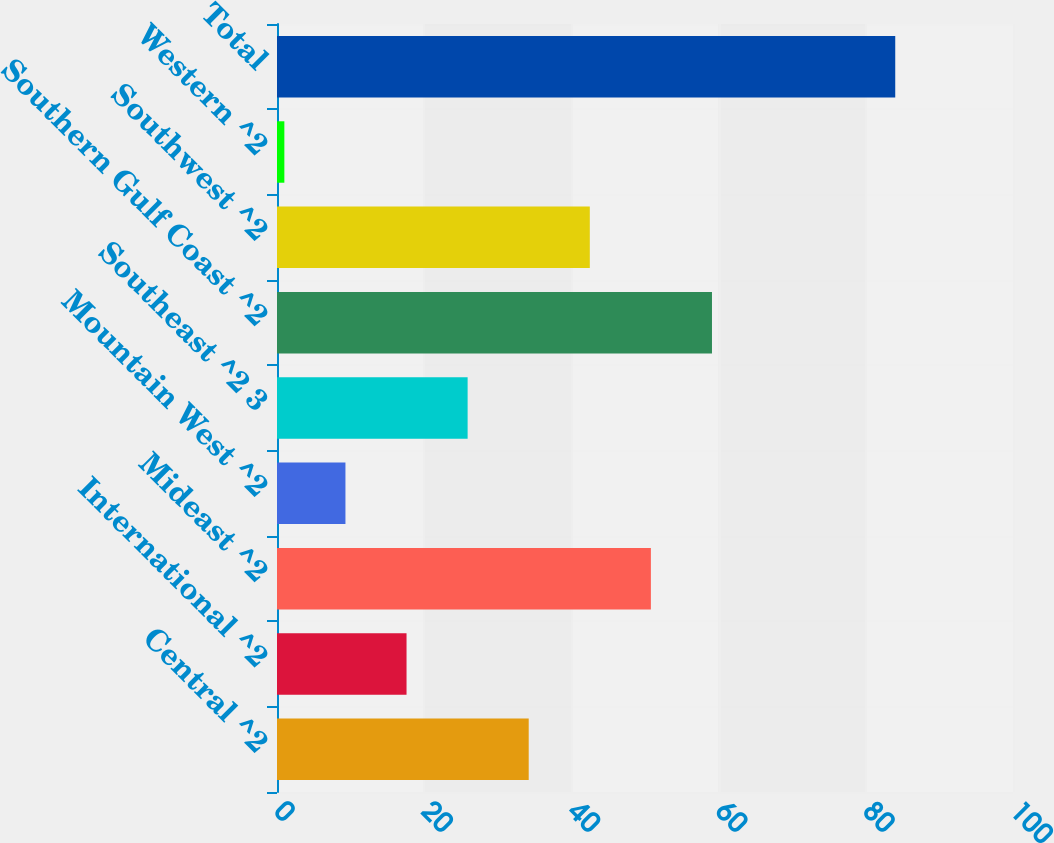Convert chart to OTSL. <chart><loc_0><loc_0><loc_500><loc_500><bar_chart><fcel>Central ^2<fcel>International ^2<fcel>Mideast ^2<fcel>Mountain West ^2<fcel>Southeast ^2 3<fcel>Southern Gulf Coast ^2<fcel>Southwest ^2<fcel>Western ^2<fcel>Total<nl><fcel>34.2<fcel>17.6<fcel>50.8<fcel>9.3<fcel>25.9<fcel>59.1<fcel>42.5<fcel>1<fcel>84<nl></chart> 